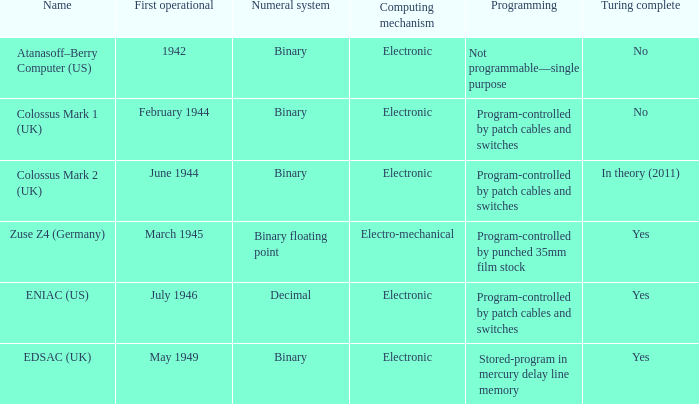What's the computing mechanbeingm with name being atanasoff–berry computer (us) Electronic. 